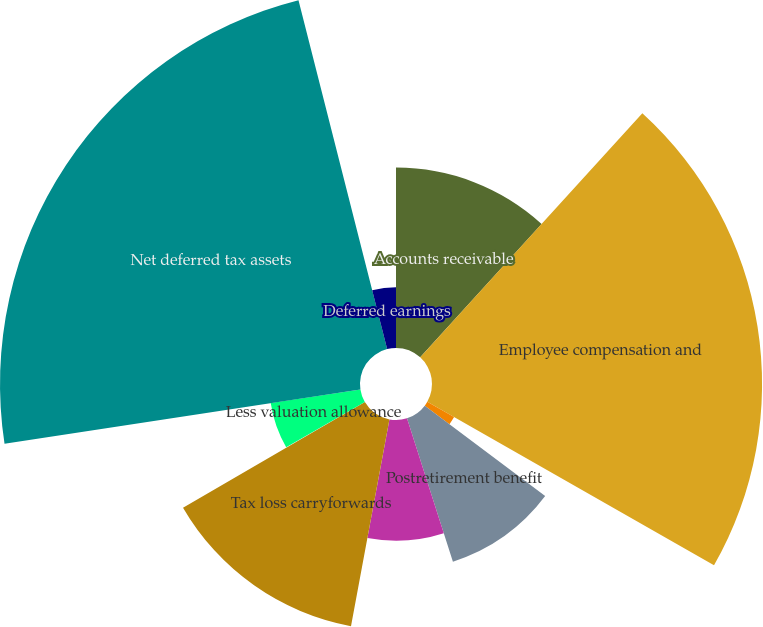<chart> <loc_0><loc_0><loc_500><loc_500><pie_chart><fcel>Accounts receivable<fcel>Employee compensation and<fcel>Self insurance reserves<fcel>Postretirement benefit<fcel>Acquisition and restructuring<fcel>Tax loss carryforwards<fcel>Other<fcel>Less valuation allowance<fcel>Net deferred tax assets<fcel>Deferred earnings<nl><fcel>11.75%<fcel>21.5%<fcel>2.01%<fcel>9.81%<fcel>7.86%<fcel>13.7%<fcel>0.06%<fcel>5.91%<fcel>23.45%<fcel>3.96%<nl></chart> 